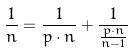<formula> <loc_0><loc_0><loc_500><loc_500>\frac { 1 } { n } = \frac { 1 } { p \cdot n } + \frac { 1 } { \frac { p \cdot n } { n - 1 } }</formula> 